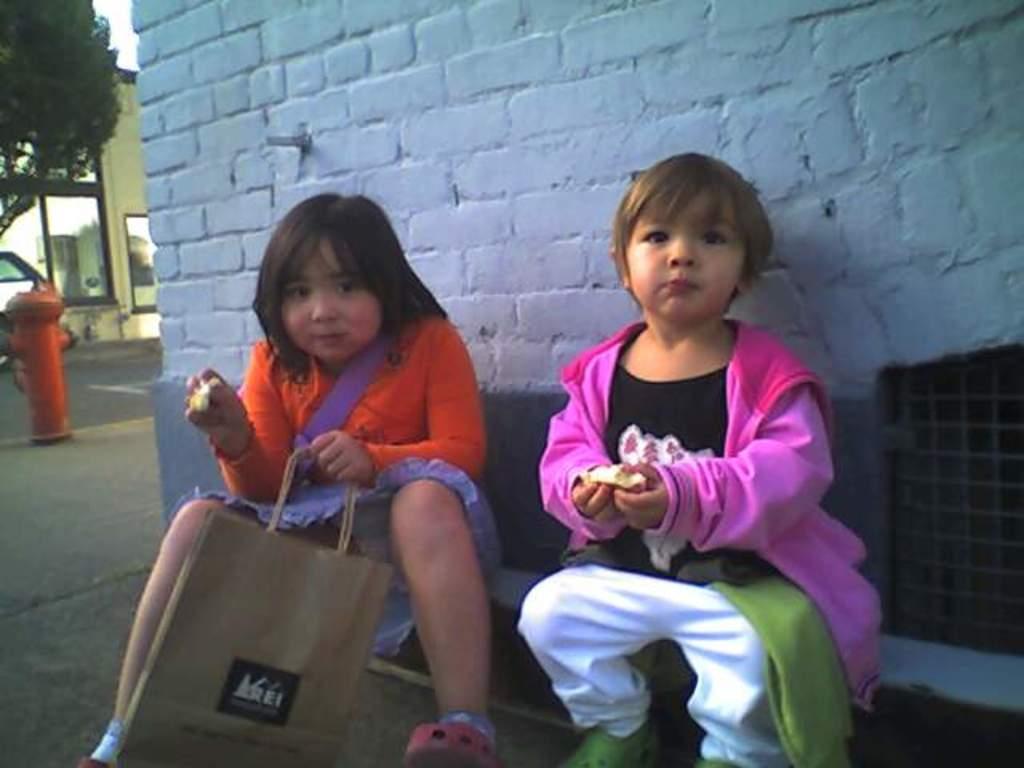How would you summarize this image in a sentence or two? In this picture I can see there are two girls sitting here and they are eating something and there is a wall in the backdrop and there are trees, building and the sky is clear. 